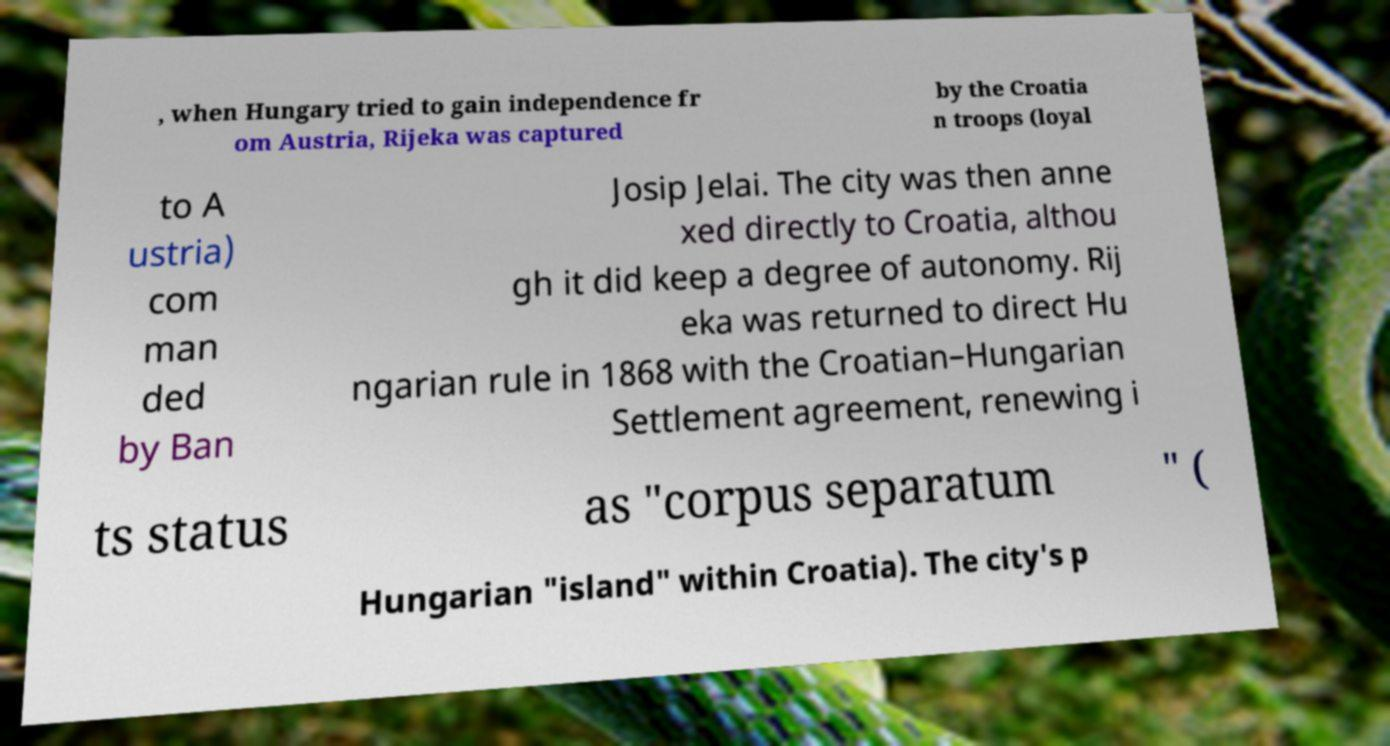For documentation purposes, I need the text within this image transcribed. Could you provide that? , when Hungary tried to gain independence fr om Austria, Rijeka was captured by the Croatia n troops (loyal to A ustria) com man ded by Ban Josip Jelai. The city was then anne xed directly to Croatia, althou gh it did keep a degree of autonomy. Rij eka was returned to direct Hu ngarian rule in 1868 with the Croatian–Hungarian Settlement agreement, renewing i ts status as "corpus separatum " ( Hungarian "island" within Croatia). The city's p 